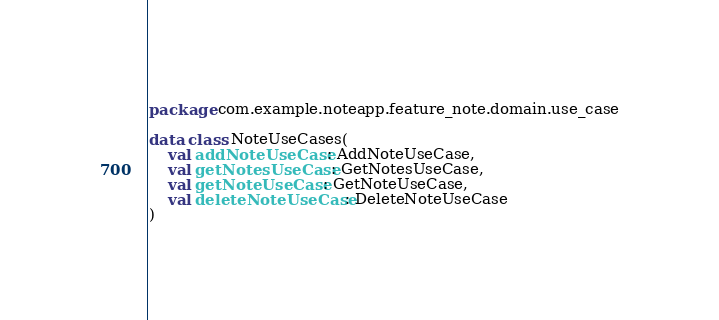<code> <loc_0><loc_0><loc_500><loc_500><_Kotlin_>package com.example.noteapp.feature_note.domain.use_case

data class NoteUseCases(
    val addNoteUseCase: AddNoteUseCase,
    val getNotesUseCase: GetNotesUseCase,
    val getNoteUseCase: GetNoteUseCase,
    val deleteNoteUseCase: DeleteNoteUseCase
)
</code> 